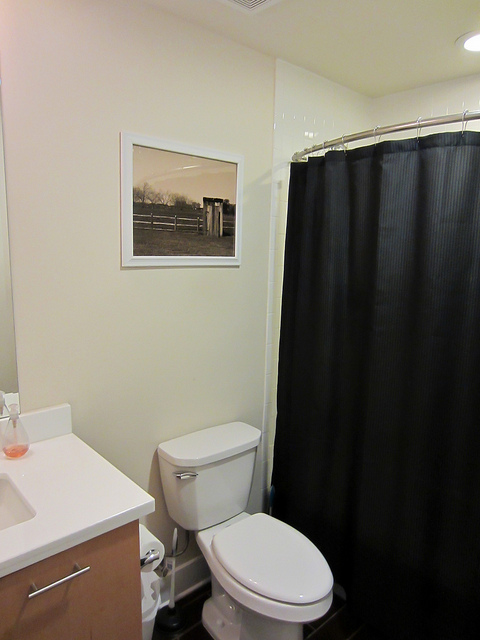<image>What is the pattern on the shower curtains? I am not sure. The pattern on the shower curtains could either be solid, plain, or black. There might also be no pattern. What is the pattern on the shower curtains? There is no clear answer to what the pattern on the shower curtains is. It can be seen as plain, plaid, solid, or none. 